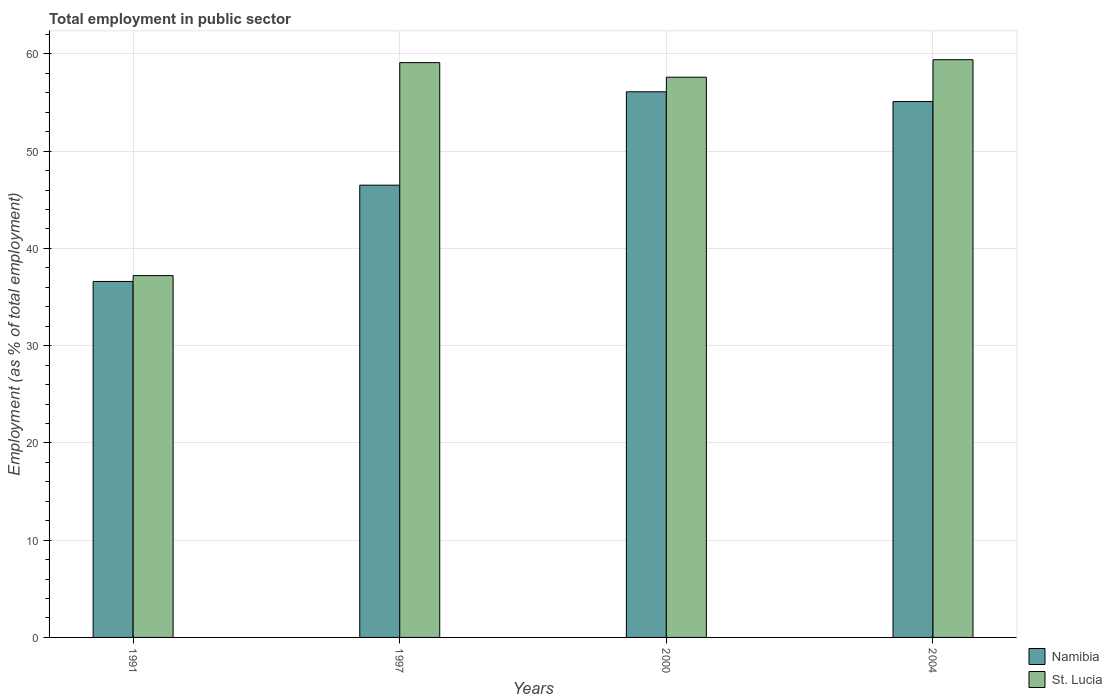How many different coloured bars are there?
Your response must be concise. 2. How many groups of bars are there?
Offer a terse response. 4. Are the number of bars on each tick of the X-axis equal?
Keep it short and to the point. Yes. How many bars are there on the 4th tick from the left?
Give a very brief answer. 2. How many bars are there on the 4th tick from the right?
Offer a very short reply. 2. What is the employment in public sector in St. Lucia in 1997?
Your answer should be compact. 59.1. Across all years, what is the maximum employment in public sector in Namibia?
Make the answer very short. 56.1. Across all years, what is the minimum employment in public sector in Namibia?
Ensure brevity in your answer.  36.6. In which year was the employment in public sector in St. Lucia maximum?
Provide a succinct answer. 2004. What is the total employment in public sector in St. Lucia in the graph?
Provide a succinct answer. 213.3. What is the difference between the employment in public sector in Namibia in 1997 and that in 2004?
Ensure brevity in your answer.  -8.6. What is the difference between the employment in public sector in Namibia in 2000 and the employment in public sector in St. Lucia in 2004?
Keep it short and to the point. -3.3. What is the average employment in public sector in Namibia per year?
Your response must be concise. 48.57. In the year 1991, what is the difference between the employment in public sector in Namibia and employment in public sector in St. Lucia?
Provide a short and direct response. -0.6. In how many years, is the employment in public sector in Namibia greater than 38 %?
Ensure brevity in your answer.  3. What is the ratio of the employment in public sector in St. Lucia in 2000 to that in 2004?
Your answer should be very brief. 0.97. Is the difference between the employment in public sector in Namibia in 2000 and 2004 greater than the difference between the employment in public sector in St. Lucia in 2000 and 2004?
Your answer should be compact. Yes. In how many years, is the employment in public sector in Namibia greater than the average employment in public sector in Namibia taken over all years?
Your answer should be compact. 2. Is the sum of the employment in public sector in St. Lucia in 1991 and 1997 greater than the maximum employment in public sector in Namibia across all years?
Offer a very short reply. Yes. What does the 2nd bar from the left in 2000 represents?
Offer a very short reply. St. Lucia. What does the 2nd bar from the right in 2004 represents?
Provide a short and direct response. Namibia. How many bars are there?
Your response must be concise. 8. How many years are there in the graph?
Keep it short and to the point. 4. What is the difference between two consecutive major ticks on the Y-axis?
Provide a short and direct response. 10. Does the graph contain any zero values?
Your answer should be compact. No. Does the graph contain grids?
Give a very brief answer. Yes. Where does the legend appear in the graph?
Keep it short and to the point. Bottom right. How many legend labels are there?
Offer a very short reply. 2. How are the legend labels stacked?
Offer a terse response. Vertical. What is the title of the graph?
Give a very brief answer. Total employment in public sector. Does "Croatia" appear as one of the legend labels in the graph?
Offer a terse response. No. What is the label or title of the Y-axis?
Offer a terse response. Employment (as % of total employment). What is the Employment (as % of total employment) in Namibia in 1991?
Offer a terse response. 36.6. What is the Employment (as % of total employment) in St. Lucia in 1991?
Offer a very short reply. 37.2. What is the Employment (as % of total employment) of Namibia in 1997?
Give a very brief answer. 46.5. What is the Employment (as % of total employment) in St. Lucia in 1997?
Give a very brief answer. 59.1. What is the Employment (as % of total employment) in Namibia in 2000?
Your answer should be very brief. 56.1. What is the Employment (as % of total employment) of St. Lucia in 2000?
Your answer should be compact. 57.6. What is the Employment (as % of total employment) of Namibia in 2004?
Keep it short and to the point. 55.1. What is the Employment (as % of total employment) of St. Lucia in 2004?
Provide a short and direct response. 59.4. Across all years, what is the maximum Employment (as % of total employment) in Namibia?
Provide a succinct answer. 56.1. Across all years, what is the maximum Employment (as % of total employment) in St. Lucia?
Provide a succinct answer. 59.4. Across all years, what is the minimum Employment (as % of total employment) of Namibia?
Keep it short and to the point. 36.6. Across all years, what is the minimum Employment (as % of total employment) in St. Lucia?
Provide a short and direct response. 37.2. What is the total Employment (as % of total employment) in Namibia in the graph?
Ensure brevity in your answer.  194.3. What is the total Employment (as % of total employment) of St. Lucia in the graph?
Keep it short and to the point. 213.3. What is the difference between the Employment (as % of total employment) of Namibia in 1991 and that in 1997?
Provide a succinct answer. -9.9. What is the difference between the Employment (as % of total employment) of St. Lucia in 1991 and that in 1997?
Offer a very short reply. -21.9. What is the difference between the Employment (as % of total employment) in Namibia in 1991 and that in 2000?
Your answer should be very brief. -19.5. What is the difference between the Employment (as % of total employment) in St. Lucia in 1991 and that in 2000?
Your response must be concise. -20.4. What is the difference between the Employment (as % of total employment) in Namibia in 1991 and that in 2004?
Keep it short and to the point. -18.5. What is the difference between the Employment (as % of total employment) of St. Lucia in 1991 and that in 2004?
Give a very brief answer. -22.2. What is the difference between the Employment (as % of total employment) in St. Lucia in 1997 and that in 2000?
Your answer should be very brief. 1.5. What is the difference between the Employment (as % of total employment) in Namibia in 2000 and that in 2004?
Offer a terse response. 1. What is the difference between the Employment (as % of total employment) in St. Lucia in 2000 and that in 2004?
Provide a short and direct response. -1.8. What is the difference between the Employment (as % of total employment) in Namibia in 1991 and the Employment (as % of total employment) in St. Lucia in 1997?
Offer a very short reply. -22.5. What is the difference between the Employment (as % of total employment) of Namibia in 1991 and the Employment (as % of total employment) of St. Lucia in 2004?
Offer a terse response. -22.8. What is the difference between the Employment (as % of total employment) of Namibia in 2000 and the Employment (as % of total employment) of St. Lucia in 2004?
Your answer should be very brief. -3.3. What is the average Employment (as % of total employment) of Namibia per year?
Your answer should be compact. 48.58. What is the average Employment (as % of total employment) of St. Lucia per year?
Keep it short and to the point. 53.33. In the year 1991, what is the difference between the Employment (as % of total employment) of Namibia and Employment (as % of total employment) of St. Lucia?
Give a very brief answer. -0.6. In the year 1997, what is the difference between the Employment (as % of total employment) of Namibia and Employment (as % of total employment) of St. Lucia?
Your answer should be compact. -12.6. What is the ratio of the Employment (as % of total employment) of Namibia in 1991 to that in 1997?
Ensure brevity in your answer.  0.79. What is the ratio of the Employment (as % of total employment) of St. Lucia in 1991 to that in 1997?
Offer a very short reply. 0.63. What is the ratio of the Employment (as % of total employment) in Namibia in 1991 to that in 2000?
Offer a very short reply. 0.65. What is the ratio of the Employment (as % of total employment) in St. Lucia in 1991 to that in 2000?
Your answer should be very brief. 0.65. What is the ratio of the Employment (as % of total employment) in Namibia in 1991 to that in 2004?
Your answer should be very brief. 0.66. What is the ratio of the Employment (as % of total employment) of St. Lucia in 1991 to that in 2004?
Give a very brief answer. 0.63. What is the ratio of the Employment (as % of total employment) in Namibia in 1997 to that in 2000?
Your answer should be very brief. 0.83. What is the ratio of the Employment (as % of total employment) in Namibia in 1997 to that in 2004?
Offer a terse response. 0.84. What is the ratio of the Employment (as % of total employment) in Namibia in 2000 to that in 2004?
Give a very brief answer. 1.02. What is the ratio of the Employment (as % of total employment) in St. Lucia in 2000 to that in 2004?
Provide a succinct answer. 0.97. What is the difference between the highest and the second highest Employment (as % of total employment) in Namibia?
Your answer should be compact. 1. What is the difference between the highest and the second highest Employment (as % of total employment) in St. Lucia?
Give a very brief answer. 0.3. What is the difference between the highest and the lowest Employment (as % of total employment) in Namibia?
Ensure brevity in your answer.  19.5. 